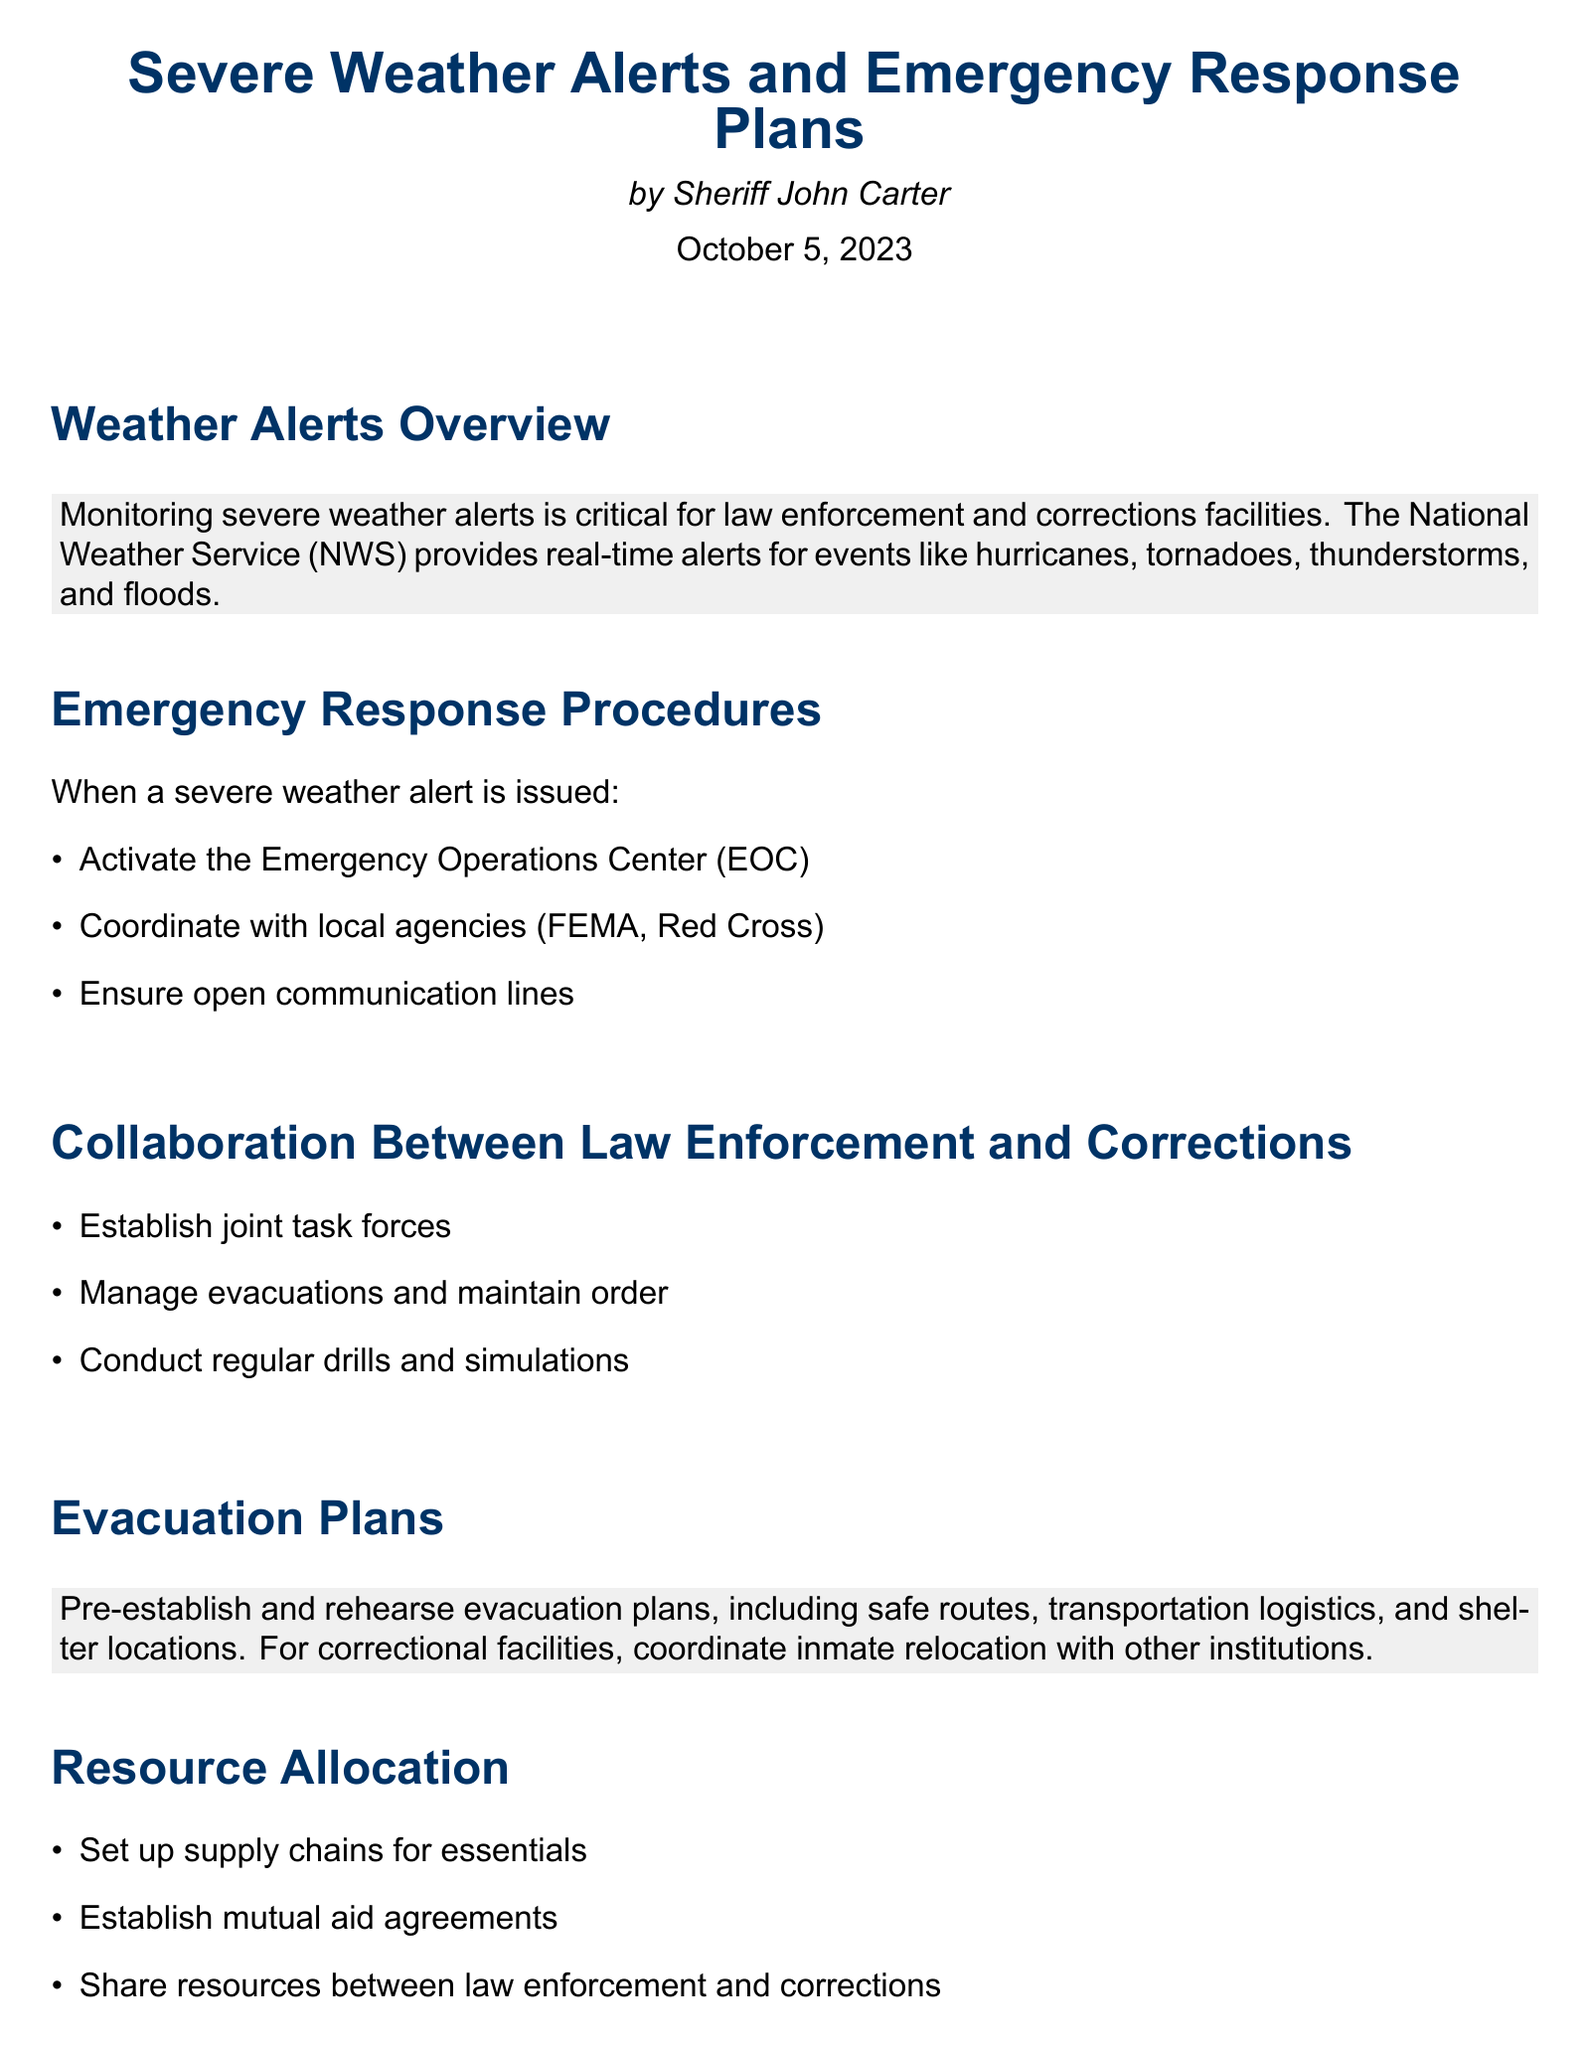what is the title of the document? The title appears at the top of the document and is "Severe Weather Alerts and Emergency Response Plans."
Answer: Severe Weather Alerts and Emergency Response Plans who is the author of the report? The author is mentioned beneath the title as Sheriff John Carter.
Answer: Sheriff John Carter what date was the report published? The publication date is listed at the beginning of the document as October 5, 2023.
Answer: October 5, 2023 what should be activated when a severe weather alert is issued? The Emergency Operations Center (EOC) is to be activated according to the procedures.
Answer: Emergency Operations Center (EOC) which agency should be coordinated with during a severe weather alert? The document mentions coordinating with local agencies such as FEMA and the Red Cross.
Answer: FEMA, Red Cross what is one key aspect of collaboration between law enforcement and corrections? A key aspect mentioned is the establishment of joint task forces for effective response.
Answer: Joint task forces how often should training and drills be conducted? The document suggests that regular training and drills should be conducted, implying a continuous effort.
Answer: Regularly what should communication protocols utilize? Multiple channels like radio, mobile, and internet are to be used for communication.
Answer: Multiple channels what is a focus area of resource allocation? Setting up supply chains for essentials is a highlight in the resource allocation section.
Answer: Supply chains for essentials 